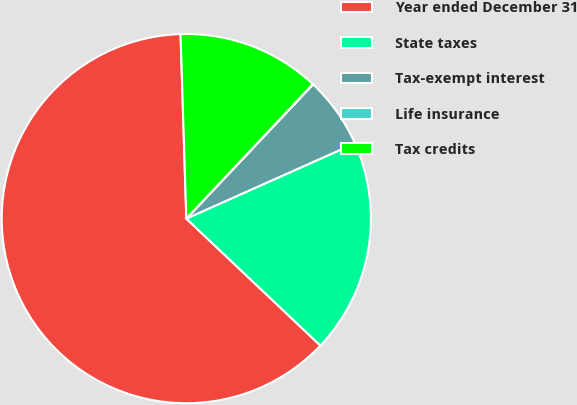Convert chart. <chart><loc_0><loc_0><loc_500><loc_500><pie_chart><fcel>Year ended December 31<fcel>State taxes<fcel>Tax-exempt interest<fcel>Life insurance<fcel>Tax credits<nl><fcel>62.43%<fcel>18.75%<fcel>6.27%<fcel>0.03%<fcel>12.51%<nl></chart> 